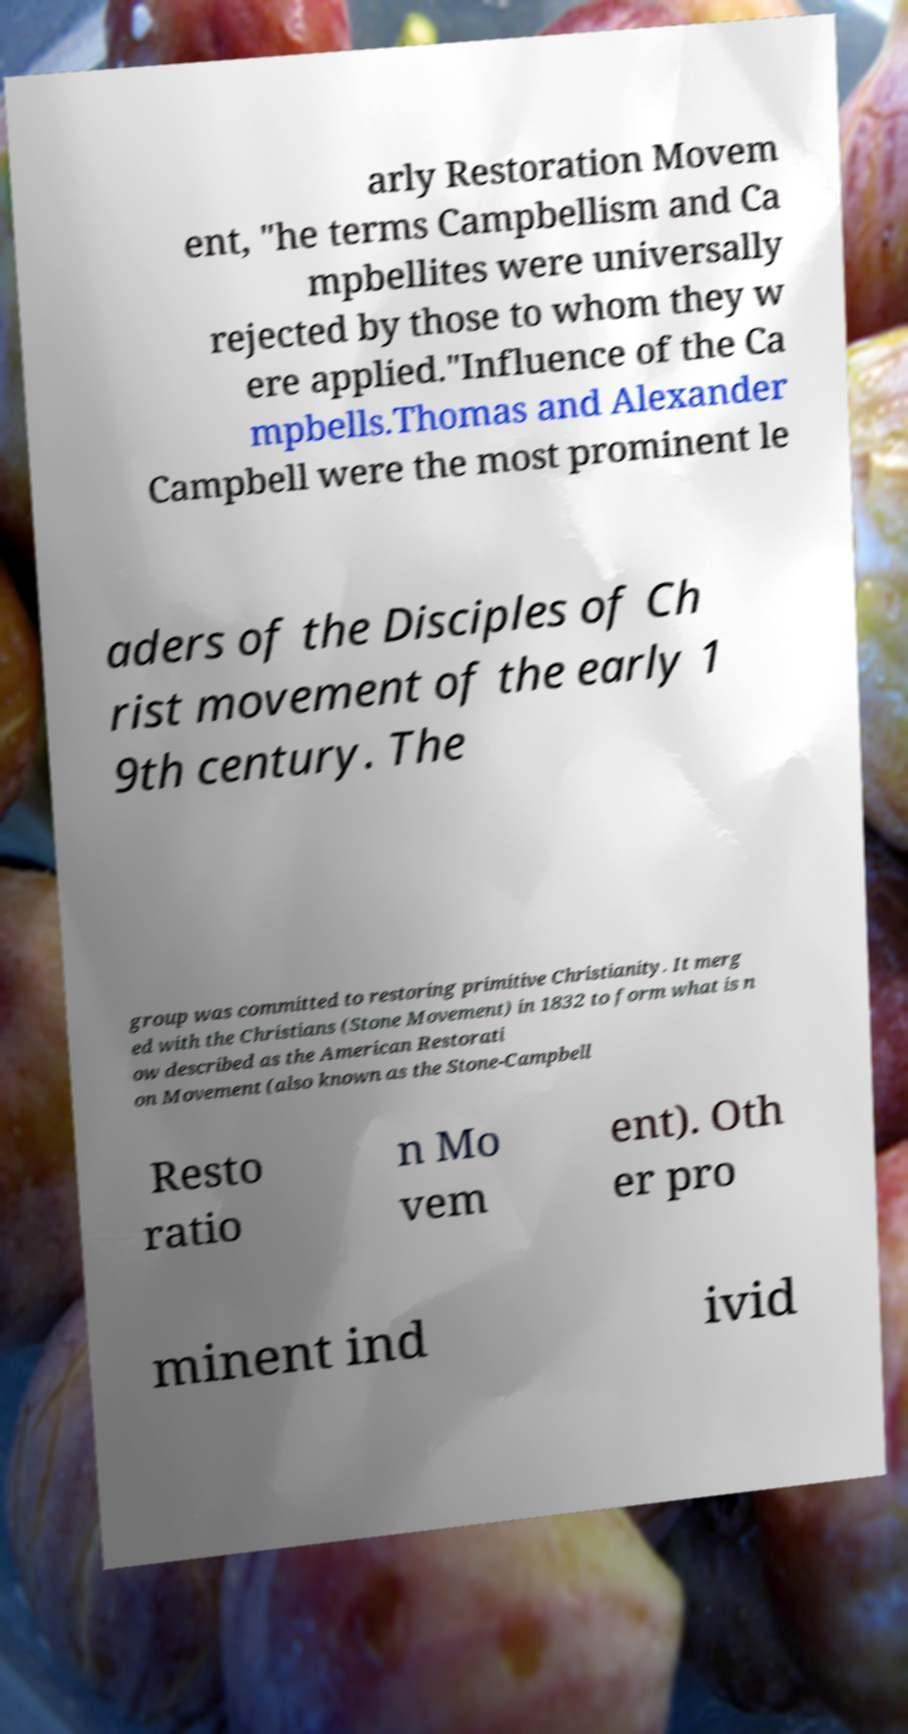What messages or text are displayed in this image? I need them in a readable, typed format. arly Restoration Movem ent, "he terms Campbellism and Ca mpbellites were universally rejected by those to whom they w ere applied."Influence of the Ca mpbells.Thomas and Alexander Campbell were the most prominent le aders of the Disciples of Ch rist movement of the early 1 9th century. The group was committed to restoring primitive Christianity. It merg ed with the Christians (Stone Movement) in 1832 to form what is n ow described as the American Restorati on Movement (also known as the Stone-Campbell Resto ratio n Mo vem ent). Oth er pro minent ind ivid 